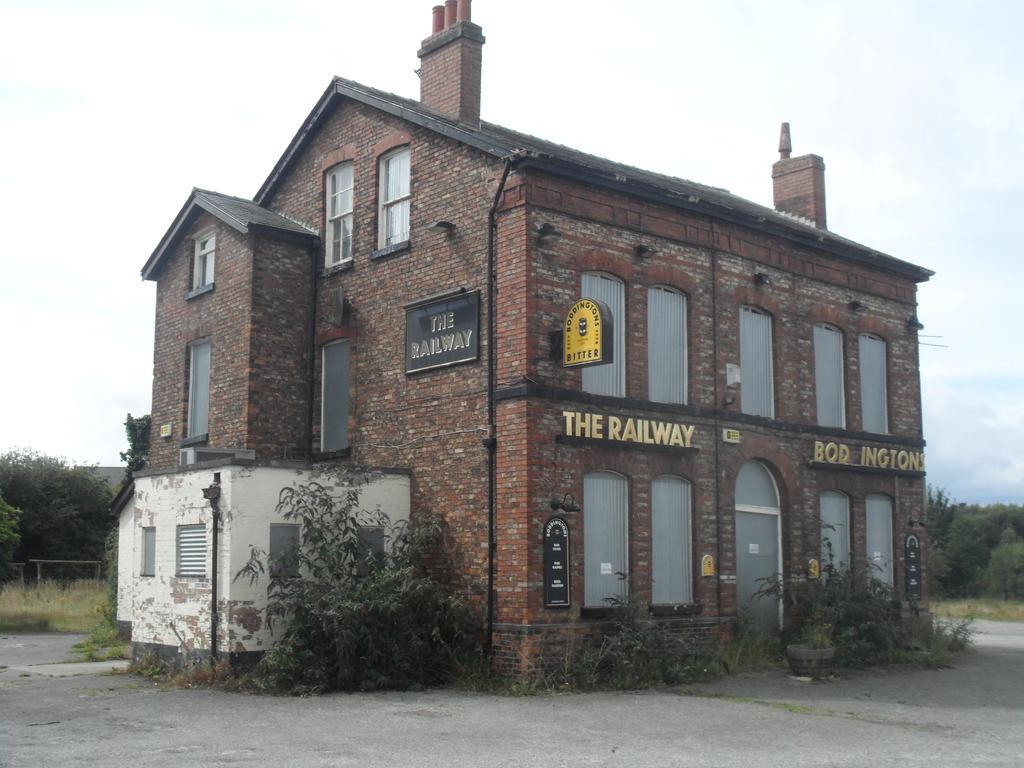Can you describe this image briefly? In this image I can see the building which is in brown color. I can see there are the black color boards to the building. To the side of the building there are many trees. In the back I can see the white sky. 